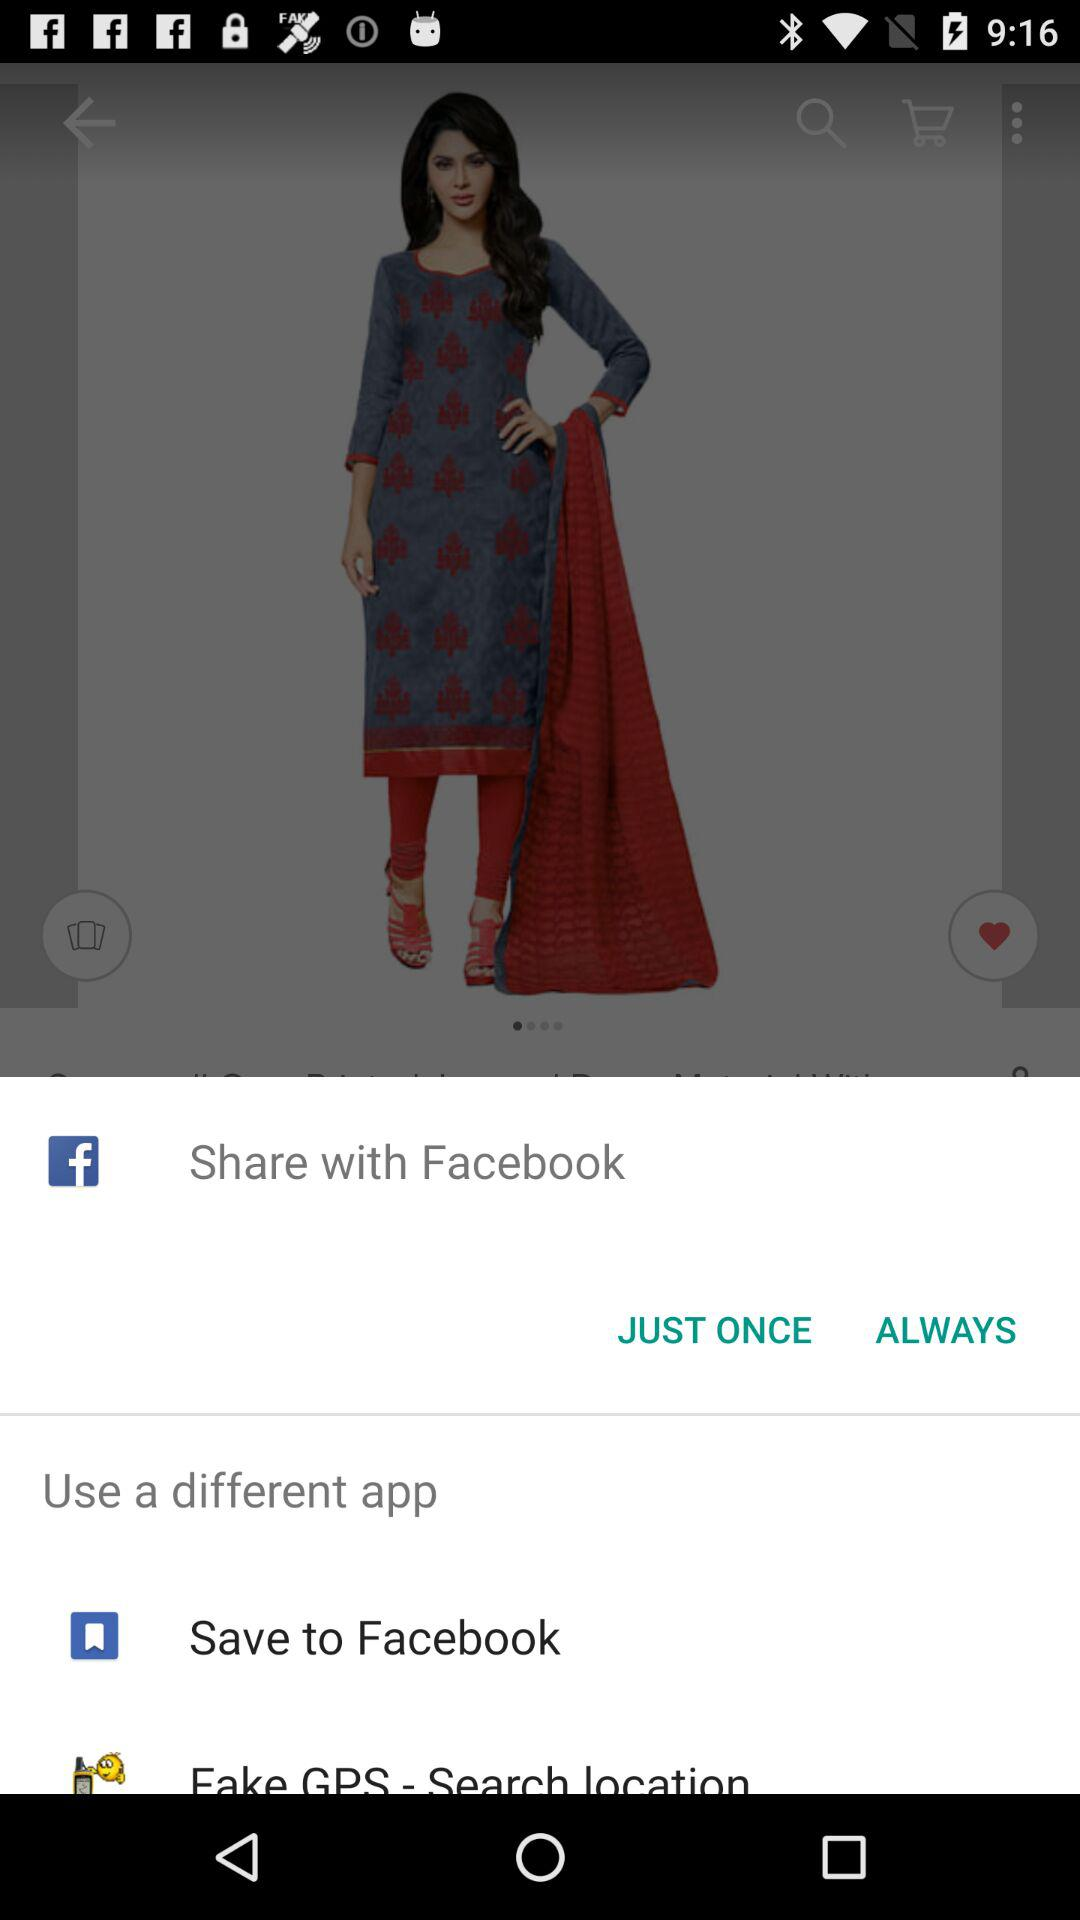What applications are used to share? The application is "Facebook". 